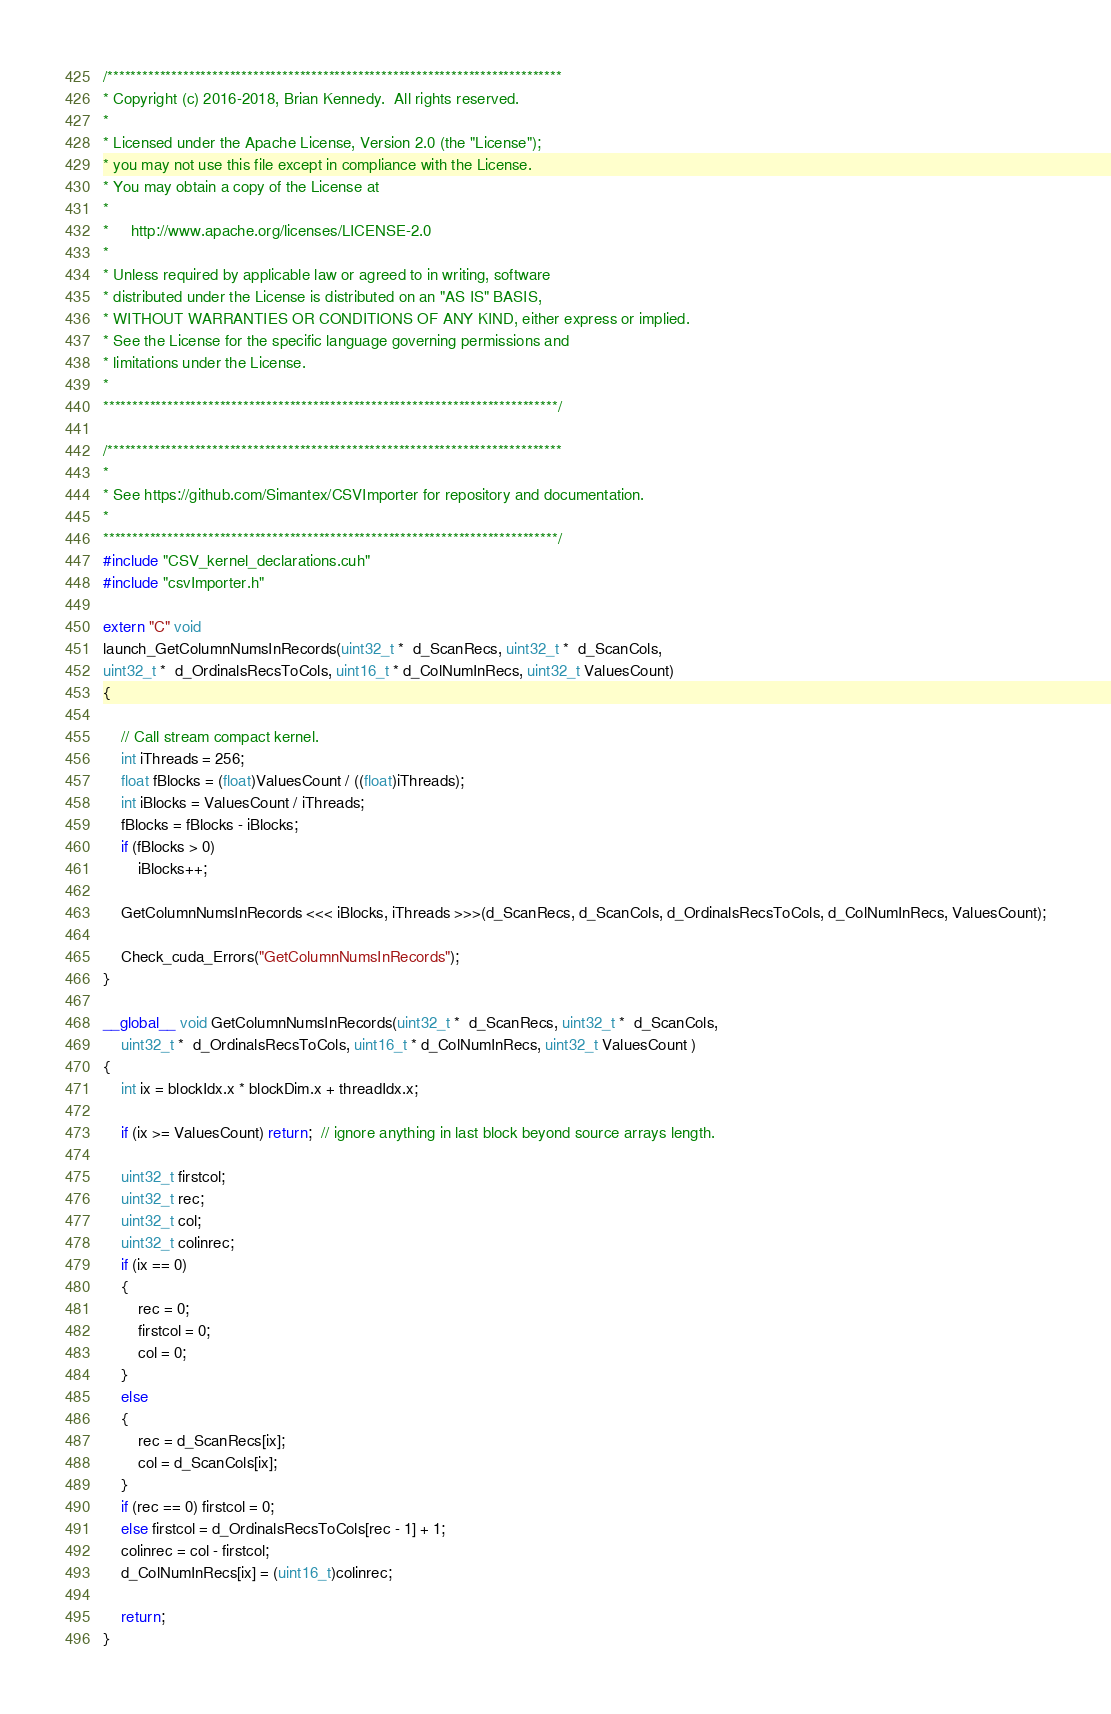<code> <loc_0><loc_0><loc_500><loc_500><_Cuda_>/******************************************************************************
* Copyright (c) 2016-2018, Brian Kennedy.  All rights reserved.
*
* Licensed under the Apache License, Version 2.0 (the "License");
* you may not use this file except in compliance with the License.
* You may obtain a copy of the License at
*
*     http://www.apache.org/licenses/LICENSE-2.0
*
* Unless required by applicable law or agreed to in writing, software
* distributed under the License is distributed on an "AS IS" BASIS,
* WITHOUT WARRANTIES OR CONDITIONS OF ANY KIND, either express or implied.
* See the License for the specific language governing permissions and
* limitations under the License.
*
******************************************************************************/

/******************************************************************************
*
* See https://github.com/Simantex/CSVImporter for repository and documentation.
*
******************************************************************************/
#include "CSV_kernel_declarations.cuh"
#include "csvImporter.h"

extern "C" void
launch_GetColumnNumsInRecords(uint32_t *  d_ScanRecs, uint32_t *  d_ScanCols,
uint32_t *  d_OrdinalsRecsToCols, uint16_t * d_ColNumInRecs, uint32_t ValuesCount)
{

	// Call stream compact kernel.
	int iThreads = 256;
	float fBlocks = (float)ValuesCount / ((float)iThreads);
	int iBlocks = ValuesCount / iThreads;
	fBlocks = fBlocks - iBlocks;
	if (fBlocks > 0)
		iBlocks++;

	GetColumnNumsInRecords <<< iBlocks, iThreads >>>(d_ScanRecs, d_ScanCols, d_OrdinalsRecsToCols, d_ColNumInRecs, ValuesCount);

	Check_cuda_Errors("GetColumnNumsInRecords");
}

__global__ void GetColumnNumsInRecords(uint32_t *  d_ScanRecs, uint32_t *  d_ScanCols,
	uint32_t *  d_OrdinalsRecsToCols, uint16_t * d_ColNumInRecs, uint32_t ValuesCount )
{
	int ix = blockIdx.x * blockDim.x + threadIdx.x;

	if (ix >= ValuesCount) return;  // ignore anything in last block beyond source arrays length.

	uint32_t firstcol;
	uint32_t rec;
	uint32_t col;
	uint32_t colinrec;
	if (ix == 0)
	{
		rec = 0;
		firstcol = 0;
		col = 0;
	}
	else
	{
		rec = d_ScanRecs[ix];
		col = d_ScanCols[ix];
	}
	if (rec == 0) firstcol = 0;
	else firstcol = d_OrdinalsRecsToCols[rec - 1] + 1;
	colinrec = col - firstcol;
	d_ColNumInRecs[ix] = (uint16_t)colinrec;

	return;
}</code> 